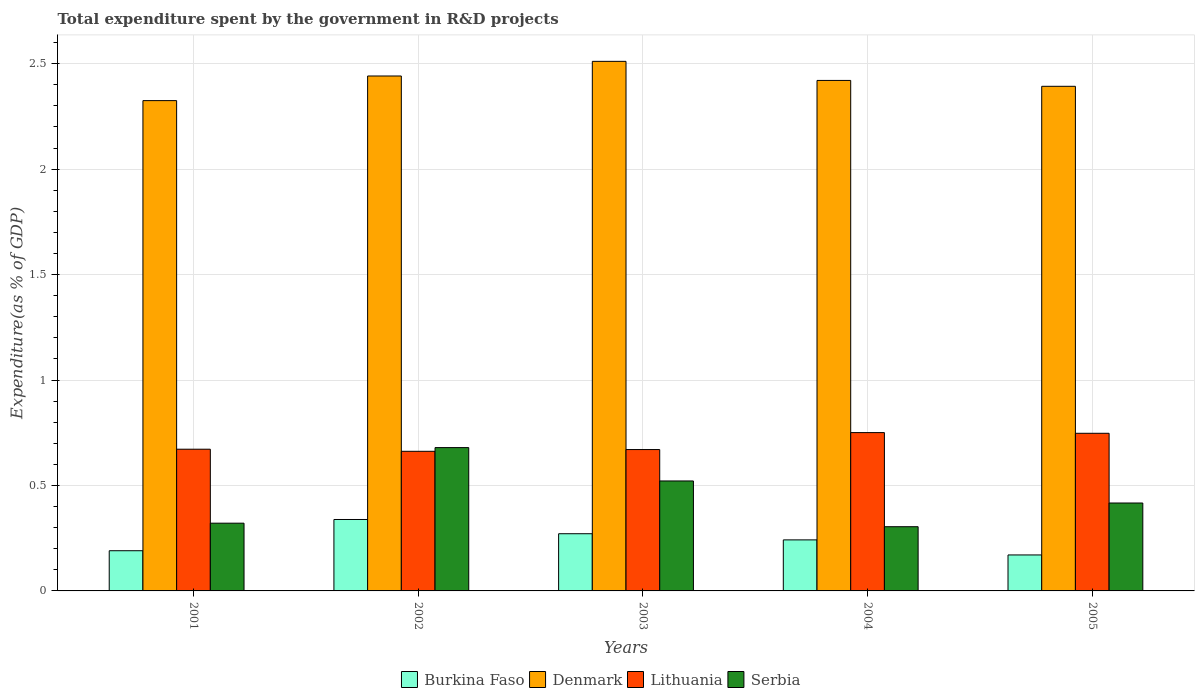How many different coloured bars are there?
Your answer should be very brief. 4. In how many cases, is the number of bars for a given year not equal to the number of legend labels?
Your answer should be compact. 0. What is the total expenditure spent by the government in R&D projects in Lithuania in 2001?
Offer a terse response. 0.67. Across all years, what is the maximum total expenditure spent by the government in R&D projects in Denmark?
Keep it short and to the point. 2.51. Across all years, what is the minimum total expenditure spent by the government in R&D projects in Denmark?
Give a very brief answer. 2.32. In which year was the total expenditure spent by the government in R&D projects in Burkina Faso minimum?
Provide a succinct answer. 2005. What is the total total expenditure spent by the government in R&D projects in Denmark in the graph?
Keep it short and to the point. 12.09. What is the difference between the total expenditure spent by the government in R&D projects in Serbia in 2002 and that in 2004?
Your answer should be very brief. 0.38. What is the difference between the total expenditure spent by the government in R&D projects in Burkina Faso in 2003 and the total expenditure spent by the government in R&D projects in Lithuania in 2004?
Make the answer very short. -0.48. What is the average total expenditure spent by the government in R&D projects in Burkina Faso per year?
Offer a terse response. 0.24. In the year 2004, what is the difference between the total expenditure spent by the government in R&D projects in Denmark and total expenditure spent by the government in R&D projects in Burkina Faso?
Offer a very short reply. 2.18. What is the ratio of the total expenditure spent by the government in R&D projects in Burkina Faso in 2002 to that in 2004?
Ensure brevity in your answer.  1.4. What is the difference between the highest and the second highest total expenditure spent by the government in R&D projects in Lithuania?
Offer a very short reply. 0. What is the difference between the highest and the lowest total expenditure spent by the government in R&D projects in Lithuania?
Offer a terse response. 0.09. Is the sum of the total expenditure spent by the government in R&D projects in Lithuania in 2003 and 2005 greater than the maximum total expenditure spent by the government in R&D projects in Denmark across all years?
Keep it short and to the point. No. Is it the case that in every year, the sum of the total expenditure spent by the government in R&D projects in Lithuania and total expenditure spent by the government in R&D projects in Burkina Faso is greater than the sum of total expenditure spent by the government in R&D projects in Serbia and total expenditure spent by the government in R&D projects in Denmark?
Your answer should be compact. Yes. What does the 1st bar from the left in 2004 represents?
Ensure brevity in your answer.  Burkina Faso. What does the 4th bar from the right in 2004 represents?
Keep it short and to the point. Burkina Faso. How many bars are there?
Keep it short and to the point. 20. Are all the bars in the graph horizontal?
Make the answer very short. No. Are the values on the major ticks of Y-axis written in scientific E-notation?
Ensure brevity in your answer.  No. How many legend labels are there?
Your answer should be very brief. 4. What is the title of the graph?
Give a very brief answer. Total expenditure spent by the government in R&D projects. Does "Latin America(developing only)" appear as one of the legend labels in the graph?
Offer a very short reply. No. What is the label or title of the X-axis?
Your answer should be compact. Years. What is the label or title of the Y-axis?
Give a very brief answer. Expenditure(as % of GDP). What is the Expenditure(as % of GDP) in Burkina Faso in 2001?
Your response must be concise. 0.19. What is the Expenditure(as % of GDP) in Denmark in 2001?
Offer a terse response. 2.32. What is the Expenditure(as % of GDP) of Lithuania in 2001?
Make the answer very short. 0.67. What is the Expenditure(as % of GDP) of Serbia in 2001?
Make the answer very short. 0.32. What is the Expenditure(as % of GDP) in Burkina Faso in 2002?
Keep it short and to the point. 0.34. What is the Expenditure(as % of GDP) in Denmark in 2002?
Your answer should be very brief. 2.44. What is the Expenditure(as % of GDP) in Lithuania in 2002?
Your answer should be compact. 0.66. What is the Expenditure(as % of GDP) of Serbia in 2002?
Your answer should be very brief. 0.68. What is the Expenditure(as % of GDP) of Burkina Faso in 2003?
Keep it short and to the point. 0.27. What is the Expenditure(as % of GDP) in Denmark in 2003?
Your answer should be very brief. 2.51. What is the Expenditure(as % of GDP) in Lithuania in 2003?
Ensure brevity in your answer.  0.67. What is the Expenditure(as % of GDP) in Serbia in 2003?
Keep it short and to the point. 0.52. What is the Expenditure(as % of GDP) of Burkina Faso in 2004?
Your answer should be very brief. 0.24. What is the Expenditure(as % of GDP) of Denmark in 2004?
Your answer should be very brief. 2.42. What is the Expenditure(as % of GDP) of Lithuania in 2004?
Your response must be concise. 0.75. What is the Expenditure(as % of GDP) of Serbia in 2004?
Your answer should be very brief. 0.3. What is the Expenditure(as % of GDP) in Burkina Faso in 2005?
Offer a terse response. 0.17. What is the Expenditure(as % of GDP) in Denmark in 2005?
Give a very brief answer. 2.39. What is the Expenditure(as % of GDP) of Lithuania in 2005?
Offer a terse response. 0.75. What is the Expenditure(as % of GDP) of Serbia in 2005?
Make the answer very short. 0.42. Across all years, what is the maximum Expenditure(as % of GDP) of Burkina Faso?
Provide a succinct answer. 0.34. Across all years, what is the maximum Expenditure(as % of GDP) in Denmark?
Your response must be concise. 2.51. Across all years, what is the maximum Expenditure(as % of GDP) of Lithuania?
Ensure brevity in your answer.  0.75. Across all years, what is the maximum Expenditure(as % of GDP) of Serbia?
Your answer should be very brief. 0.68. Across all years, what is the minimum Expenditure(as % of GDP) of Burkina Faso?
Your answer should be very brief. 0.17. Across all years, what is the minimum Expenditure(as % of GDP) in Denmark?
Ensure brevity in your answer.  2.32. Across all years, what is the minimum Expenditure(as % of GDP) of Lithuania?
Make the answer very short. 0.66. Across all years, what is the minimum Expenditure(as % of GDP) of Serbia?
Offer a very short reply. 0.3. What is the total Expenditure(as % of GDP) in Burkina Faso in the graph?
Provide a short and direct response. 1.21. What is the total Expenditure(as % of GDP) in Denmark in the graph?
Offer a terse response. 12.09. What is the total Expenditure(as % of GDP) of Lithuania in the graph?
Give a very brief answer. 3.5. What is the total Expenditure(as % of GDP) of Serbia in the graph?
Give a very brief answer. 2.24. What is the difference between the Expenditure(as % of GDP) of Burkina Faso in 2001 and that in 2002?
Provide a short and direct response. -0.15. What is the difference between the Expenditure(as % of GDP) in Denmark in 2001 and that in 2002?
Your answer should be compact. -0.12. What is the difference between the Expenditure(as % of GDP) in Lithuania in 2001 and that in 2002?
Provide a short and direct response. 0.01. What is the difference between the Expenditure(as % of GDP) of Serbia in 2001 and that in 2002?
Give a very brief answer. -0.36. What is the difference between the Expenditure(as % of GDP) of Burkina Faso in 2001 and that in 2003?
Keep it short and to the point. -0.08. What is the difference between the Expenditure(as % of GDP) of Denmark in 2001 and that in 2003?
Your answer should be compact. -0.19. What is the difference between the Expenditure(as % of GDP) in Lithuania in 2001 and that in 2003?
Make the answer very short. 0. What is the difference between the Expenditure(as % of GDP) in Serbia in 2001 and that in 2003?
Ensure brevity in your answer.  -0.2. What is the difference between the Expenditure(as % of GDP) of Burkina Faso in 2001 and that in 2004?
Provide a succinct answer. -0.05. What is the difference between the Expenditure(as % of GDP) in Denmark in 2001 and that in 2004?
Make the answer very short. -0.1. What is the difference between the Expenditure(as % of GDP) of Lithuania in 2001 and that in 2004?
Keep it short and to the point. -0.08. What is the difference between the Expenditure(as % of GDP) of Serbia in 2001 and that in 2004?
Make the answer very short. 0.02. What is the difference between the Expenditure(as % of GDP) in Denmark in 2001 and that in 2005?
Your response must be concise. -0.07. What is the difference between the Expenditure(as % of GDP) of Lithuania in 2001 and that in 2005?
Offer a terse response. -0.08. What is the difference between the Expenditure(as % of GDP) in Serbia in 2001 and that in 2005?
Give a very brief answer. -0.1. What is the difference between the Expenditure(as % of GDP) of Burkina Faso in 2002 and that in 2003?
Provide a succinct answer. 0.07. What is the difference between the Expenditure(as % of GDP) of Denmark in 2002 and that in 2003?
Your answer should be compact. -0.07. What is the difference between the Expenditure(as % of GDP) in Lithuania in 2002 and that in 2003?
Ensure brevity in your answer.  -0.01. What is the difference between the Expenditure(as % of GDP) of Serbia in 2002 and that in 2003?
Keep it short and to the point. 0.16. What is the difference between the Expenditure(as % of GDP) in Burkina Faso in 2002 and that in 2004?
Keep it short and to the point. 0.1. What is the difference between the Expenditure(as % of GDP) in Denmark in 2002 and that in 2004?
Keep it short and to the point. 0.02. What is the difference between the Expenditure(as % of GDP) in Lithuania in 2002 and that in 2004?
Provide a short and direct response. -0.09. What is the difference between the Expenditure(as % of GDP) in Serbia in 2002 and that in 2004?
Provide a short and direct response. 0.38. What is the difference between the Expenditure(as % of GDP) of Burkina Faso in 2002 and that in 2005?
Provide a succinct answer. 0.17. What is the difference between the Expenditure(as % of GDP) in Denmark in 2002 and that in 2005?
Keep it short and to the point. 0.05. What is the difference between the Expenditure(as % of GDP) in Lithuania in 2002 and that in 2005?
Provide a succinct answer. -0.09. What is the difference between the Expenditure(as % of GDP) in Serbia in 2002 and that in 2005?
Ensure brevity in your answer.  0.26. What is the difference between the Expenditure(as % of GDP) of Burkina Faso in 2003 and that in 2004?
Give a very brief answer. 0.03. What is the difference between the Expenditure(as % of GDP) in Denmark in 2003 and that in 2004?
Your answer should be compact. 0.09. What is the difference between the Expenditure(as % of GDP) in Lithuania in 2003 and that in 2004?
Make the answer very short. -0.08. What is the difference between the Expenditure(as % of GDP) in Serbia in 2003 and that in 2004?
Keep it short and to the point. 0.22. What is the difference between the Expenditure(as % of GDP) in Burkina Faso in 2003 and that in 2005?
Offer a terse response. 0.1. What is the difference between the Expenditure(as % of GDP) of Denmark in 2003 and that in 2005?
Offer a very short reply. 0.12. What is the difference between the Expenditure(as % of GDP) in Lithuania in 2003 and that in 2005?
Provide a succinct answer. -0.08. What is the difference between the Expenditure(as % of GDP) in Serbia in 2003 and that in 2005?
Your response must be concise. 0.1. What is the difference between the Expenditure(as % of GDP) in Burkina Faso in 2004 and that in 2005?
Your answer should be compact. 0.07. What is the difference between the Expenditure(as % of GDP) in Denmark in 2004 and that in 2005?
Your answer should be very brief. 0.03. What is the difference between the Expenditure(as % of GDP) in Lithuania in 2004 and that in 2005?
Offer a terse response. 0. What is the difference between the Expenditure(as % of GDP) in Serbia in 2004 and that in 2005?
Give a very brief answer. -0.11. What is the difference between the Expenditure(as % of GDP) in Burkina Faso in 2001 and the Expenditure(as % of GDP) in Denmark in 2002?
Ensure brevity in your answer.  -2.25. What is the difference between the Expenditure(as % of GDP) in Burkina Faso in 2001 and the Expenditure(as % of GDP) in Lithuania in 2002?
Your answer should be very brief. -0.47. What is the difference between the Expenditure(as % of GDP) of Burkina Faso in 2001 and the Expenditure(as % of GDP) of Serbia in 2002?
Offer a very short reply. -0.49. What is the difference between the Expenditure(as % of GDP) of Denmark in 2001 and the Expenditure(as % of GDP) of Lithuania in 2002?
Provide a succinct answer. 1.66. What is the difference between the Expenditure(as % of GDP) in Denmark in 2001 and the Expenditure(as % of GDP) in Serbia in 2002?
Keep it short and to the point. 1.65. What is the difference between the Expenditure(as % of GDP) in Lithuania in 2001 and the Expenditure(as % of GDP) in Serbia in 2002?
Provide a succinct answer. -0.01. What is the difference between the Expenditure(as % of GDP) in Burkina Faso in 2001 and the Expenditure(as % of GDP) in Denmark in 2003?
Keep it short and to the point. -2.32. What is the difference between the Expenditure(as % of GDP) in Burkina Faso in 2001 and the Expenditure(as % of GDP) in Lithuania in 2003?
Ensure brevity in your answer.  -0.48. What is the difference between the Expenditure(as % of GDP) in Burkina Faso in 2001 and the Expenditure(as % of GDP) in Serbia in 2003?
Give a very brief answer. -0.33. What is the difference between the Expenditure(as % of GDP) of Denmark in 2001 and the Expenditure(as % of GDP) of Lithuania in 2003?
Provide a succinct answer. 1.65. What is the difference between the Expenditure(as % of GDP) in Denmark in 2001 and the Expenditure(as % of GDP) in Serbia in 2003?
Offer a terse response. 1.8. What is the difference between the Expenditure(as % of GDP) of Lithuania in 2001 and the Expenditure(as % of GDP) of Serbia in 2003?
Your answer should be compact. 0.15. What is the difference between the Expenditure(as % of GDP) in Burkina Faso in 2001 and the Expenditure(as % of GDP) in Denmark in 2004?
Provide a succinct answer. -2.23. What is the difference between the Expenditure(as % of GDP) in Burkina Faso in 2001 and the Expenditure(as % of GDP) in Lithuania in 2004?
Your answer should be very brief. -0.56. What is the difference between the Expenditure(as % of GDP) in Burkina Faso in 2001 and the Expenditure(as % of GDP) in Serbia in 2004?
Your response must be concise. -0.11. What is the difference between the Expenditure(as % of GDP) in Denmark in 2001 and the Expenditure(as % of GDP) in Lithuania in 2004?
Make the answer very short. 1.57. What is the difference between the Expenditure(as % of GDP) of Denmark in 2001 and the Expenditure(as % of GDP) of Serbia in 2004?
Offer a terse response. 2.02. What is the difference between the Expenditure(as % of GDP) in Lithuania in 2001 and the Expenditure(as % of GDP) in Serbia in 2004?
Give a very brief answer. 0.37. What is the difference between the Expenditure(as % of GDP) in Burkina Faso in 2001 and the Expenditure(as % of GDP) in Denmark in 2005?
Make the answer very short. -2.2. What is the difference between the Expenditure(as % of GDP) of Burkina Faso in 2001 and the Expenditure(as % of GDP) of Lithuania in 2005?
Give a very brief answer. -0.56. What is the difference between the Expenditure(as % of GDP) in Burkina Faso in 2001 and the Expenditure(as % of GDP) in Serbia in 2005?
Offer a terse response. -0.23. What is the difference between the Expenditure(as % of GDP) of Denmark in 2001 and the Expenditure(as % of GDP) of Lithuania in 2005?
Provide a succinct answer. 1.58. What is the difference between the Expenditure(as % of GDP) in Denmark in 2001 and the Expenditure(as % of GDP) in Serbia in 2005?
Offer a terse response. 1.91. What is the difference between the Expenditure(as % of GDP) in Lithuania in 2001 and the Expenditure(as % of GDP) in Serbia in 2005?
Provide a succinct answer. 0.26. What is the difference between the Expenditure(as % of GDP) in Burkina Faso in 2002 and the Expenditure(as % of GDP) in Denmark in 2003?
Provide a succinct answer. -2.17. What is the difference between the Expenditure(as % of GDP) in Burkina Faso in 2002 and the Expenditure(as % of GDP) in Lithuania in 2003?
Provide a succinct answer. -0.33. What is the difference between the Expenditure(as % of GDP) in Burkina Faso in 2002 and the Expenditure(as % of GDP) in Serbia in 2003?
Provide a short and direct response. -0.18. What is the difference between the Expenditure(as % of GDP) of Denmark in 2002 and the Expenditure(as % of GDP) of Lithuania in 2003?
Provide a short and direct response. 1.77. What is the difference between the Expenditure(as % of GDP) of Denmark in 2002 and the Expenditure(as % of GDP) of Serbia in 2003?
Offer a terse response. 1.92. What is the difference between the Expenditure(as % of GDP) in Lithuania in 2002 and the Expenditure(as % of GDP) in Serbia in 2003?
Your answer should be compact. 0.14. What is the difference between the Expenditure(as % of GDP) in Burkina Faso in 2002 and the Expenditure(as % of GDP) in Denmark in 2004?
Your answer should be very brief. -2.08. What is the difference between the Expenditure(as % of GDP) of Burkina Faso in 2002 and the Expenditure(as % of GDP) of Lithuania in 2004?
Offer a very short reply. -0.41. What is the difference between the Expenditure(as % of GDP) in Burkina Faso in 2002 and the Expenditure(as % of GDP) in Serbia in 2004?
Keep it short and to the point. 0.03. What is the difference between the Expenditure(as % of GDP) in Denmark in 2002 and the Expenditure(as % of GDP) in Lithuania in 2004?
Ensure brevity in your answer.  1.69. What is the difference between the Expenditure(as % of GDP) of Denmark in 2002 and the Expenditure(as % of GDP) of Serbia in 2004?
Your answer should be very brief. 2.14. What is the difference between the Expenditure(as % of GDP) of Lithuania in 2002 and the Expenditure(as % of GDP) of Serbia in 2004?
Make the answer very short. 0.36. What is the difference between the Expenditure(as % of GDP) in Burkina Faso in 2002 and the Expenditure(as % of GDP) in Denmark in 2005?
Offer a terse response. -2.05. What is the difference between the Expenditure(as % of GDP) in Burkina Faso in 2002 and the Expenditure(as % of GDP) in Lithuania in 2005?
Your answer should be compact. -0.41. What is the difference between the Expenditure(as % of GDP) in Burkina Faso in 2002 and the Expenditure(as % of GDP) in Serbia in 2005?
Your response must be concise. -0.08. What is the difference between the Expenditure(as % of GDP) of Denmark in 2002 and the Expenditure(as % of GDP) of Lithuania in 2005?
Provide a succinct answer. 1.69. What is the difference between the Expenditure(as % of GDP) of Denmark in 2002 and the Expenditure(as % of GDP) of Serbia in 2005?
Offer a terse response. 2.02. What is the difference between the Expenditure(as % of GDP) in Lithuania in 2002 and the Expenditure(as % of GDP) in Serbia in 2005?
Provide a short and direct response. 0.25. What is the difference between the Expenditure(as % of GDP) in Burkina Faso in 2003 and the Expenditure(as % of GDP) in Denmark in 2004?
Provide a succinct answer. -2.15. What is the difference between the Expenditure(as % of GDP) in Burkina Faso in 2003 and the Expenditure(as % of GDP) in Lithuania in 2004?
Provide a short and direct response. -0.48. What is the difference between the Expenditure(as % of GDP) of Burkina Faso in 2003 and the Expenditure(as % of GDP) of Serbia in 2004?
Keep it short and to the point. -0.03. What is the difference between the Expenditure(as % of GDP) of Denmark in 2003 and the Expenditure(as % of GDP) of Lithuania in 2004?
Your response must be concise. 1.76. What is the difference between the Expenditure(as % of GDP) of Denmark in 2003 and the Expenditure(as % of GDP) of Serbia in 2004?
Keep it short and to the point. 2.21. What is the difference between the Expenditure(as % of GDP) in Lithuania in 2003 and the Expenditure(as % of GDP) in Serbia in 2004?
Offer a terse response. 0.37. What is the difference between the Expenditure(as % of GDP) of Burkina Faso in 2003 and the Expenditure(as % of GDP) of Denmark in 2005?
Offer a terse response. -2.12. What is the difference between the Expenditure(as % of GDP) of Burkina Faso in 2003 and the Expenditure(as % of GDP) of Lithuania in 2005?
Offer a terse response. -0.48. What is the difference between the Expenditure(as % of GDP) of Burkina Faso in 2003 and the Expenditure(as % of GDP) of Serbia in 2005?
Give a very brief answer. -0.15. What is the difference between the Expenditure(as % of GDP) of Denmark in 2003 and the Expenditure(as % of GDP) of Lithuania in 2005?
Keep it short and to the point. 1.76. What is the difference between the Expenditure(as % of GDP) of Denmark in 2003 and the Expenditure(as % of GDP) of Serbia in 2005?
Provide a short and direct response. 2.09. What is the difference between the Expenditure(as % of GDP) of Lithuania in 2003 and the Expenditure(as % of GDP) of Serbia in 2005?
Your response must be concise. 0.25. What is the difference between the Expenditure(as % of GDP) of Burkina Faso in 2004 and the Expenditure(as % of GDP) of Denmark in 2005?
Provide a succinct answer. -2.15. What is the difference between the Expenditure(as % of GDP) in Burkina Faso in 2004 and the Expenditure(as % of GDP) in Lithuania in 2005?
Your answer should be compact. -0.51. What is the difference between the Expenditure(as % of GDP) in Burkina Faso in 2004 and the Expenditure(as % of GDP) in Serbia in 2005?
Your answer should be very brief. -0.17. What is the difference between the Expenditure(as % of GDP) of Denmark in 2004 and the Expenditure(as % of GDP) of Lithuania in 2005?
Your answer should be very brief. 1.67. What is the difference between the Expenditure(as % of GDP) of Denmark in 2004 and the Expenditure(as % of GDP) of Serbia in 2005?
Your response must be concise. 2. What is the difference between the Expenditure(as % of GDP) in Lithuania in 2004 and the Expenditure(as % of GDP) in Serbia in 2005?
Offer a terse response. 0.33. What is the average Expenditure(as % of GDP) in Burkina Faso per year?
Give a very brief answer. 0.24. What is the average Expenditure(as % of GDP) in Denmark per year?
Provide a succinct answer. 2.42. What is the average Expenditure(as % of GDP) in Lithuania per year?
Keep it short and to the point. 0.7. What is the average Expenditure(as % of GDP) of Serbia per year?
Offer a terse response. 0.45. In the year 2001, what is the difference between the Expenditure(as % of GDP) in Burkina Faso and Expenditure(as % of GDP) in Denmark?
Provide a succinct answer. -2.13. In the year 2001, what is the difference between the Expenditure(as % of GDP) of Burkina Faso and Expenditure(as % of GDP) of Lithuania?
Provide a short and direct response. -0.48. In the year 2001, what is the difference between the Expenditure(as % of GDP) of Burkina Faso and Expenditure(as % of GDP) of Serbia?
Your response must be concise. -0.13. In the year 2001, what is the difference between the Expenditure(as % of GDP) in Denmark and Expenditure(as % of GDP) in Lithuania?
Your response must be concise. 1.65. In the year 2001, what is the difference between the Expenditure(as % of GDP) of Denmark and Expenditure(as % of GDP) of Serbia?
Your answer should be compact. 2. In the year 2001, what is the difference between the Expenditure(as % of GDP) in Lithuania and Expenditure(as % of GDP) in Serbia?
Provide a succinct answer. 0.35. In the year 2002, what is the difference between the Expenditure(as % of GDP) of Burkina Faso and Expenditure(as % of GDP) of Denmark?
Offer a terse response. -2.1. In the year 2002, what is the difference between the Expenditure(as % of GDP) of Burkina Faso and Expenditure(as % of GDP) of Lithuania?
Your answer should be compact. -0.32. In the year 2002, what is the difference between the Expenditure(as % of GDP) of Burkina Faso and Expenditure(as % of GDP) of Serbia?
Provide a succinct answer. -0.34. In the year 2002, what is the difference between the Expenditure(as % of GDP) in Denmark and Expenditure(as % of GDP) in Lithuania?
Provide a short and direct response. 1.78. In the year 2002, what is the difference between the Expenditure(as % of GDP) in Denmark and Expenditure(as % of GDP) in Serbia?
Your answer should be compact. 1.76. In the year 2002, what is the difference between the Expenditure(as % of GDP) of Lithuania and Expenditure(as % of GDP) of Serbia?
Your answer should be very brief. -0.02. In the year 2003, what is the difference between the Expenditure(as % of GDP) of Burkina Faso and Expenditure(as % of GDP) of Denmark?
Offer a terse response. -2.24. In the year 2003, what is the difference between the Expenditure(as % of GDP) of Burkina Faso and Expenditure(as % of GDP) of Lithuania?
Provide a succinct answer. -0.4. In the year 2003, what is the difference between the Expenditure(as % of GDP) of Burkina Faso and Expenditure(as % of GDP) of Serbia?
Your answer should be compact. -0.25. In the year 2003, what is the difference between the Expenditure(as % of GDP) in Denmark and Expenditure(as % of GDP) in Lithuania?
Offer a very short reply. 1.84. In the year 2003, what is the difference between the Expenditure(as % of GDP) in Denmark and Expenditure(as % of GDP) in Serbia?
Provide a short and direct response. 1.99. In the year 2003, what is the difference between the Expenditure(as % of GDP) in Lithuania and Expenditure(as % of GDP) in Serbia?
Your answer should be very brief. 0.15. In the year 2004, what is the difference between the Expenditure(as % of GDP) of Burkina Faso and Expenditure(as % of GDP) of Denmark?
Your answer should be very brief. -2.18. In the year 2004, what is the difference between the Expenditure(as % of GDP) of Burkina Faso and Expenditure(as % of GDP) of Lithuania?
Provide a succinct answer. -0.51. In the year 2004, what is the difference between the Expenditure(as % of GDP) in Burkina Faso and Expenditure(as % of GDP) in Serbia?
Provide a succinct answer. -0.06. In the year 2004, what is the difference between the Expenditure(as % of GDP) in Denmark and Expenditure(as % of GDP) in Lithuania?
Your answer should be compact. 1.67. In the year 2004, what is the difference between the Expenditure(as % of GDP) in Denmark and Expenditure(as % of GDP) in Serbia?
Offer a terse response. 2.12. In the year 2004, what is the difference between the Expenditure(as % of GDP) of Lithuania and Expenditure(as % of GDP) of Serbia?
Keep it short and to the point. 0.45. In the year 2005, what is the difference between the Expenditure(as % of GDP) of Burkina Faso and Expenditure(as % of GDP) of Denmark?
Keep it short and to the point. -2.22. In the year 2005, what is the difference between the Expenditure(as % of GDP) of Burkina Faso and Expenditure(as % of GDP) of Lithuania?
Offer a very short reply. -0.58. In the year 2005, what is the difference between the Expenditure(as % of GDP) of Burkina Faso and Expenditure(as % of GDP) of Serbia?
Keep it short and to the point. -0.25. In the year 2005, what is the difference between the Expenditure(as % of GDP) of Denmark and Expenditure(as % of GDP) of Lithuania?
Ensure brevity in your answer.  1.65. In the year 2005, what is the difference between the Expenditure(as % of GDP) in Denmark and Expenditure(as % of GDP) in Serbia?
Provide a succinct answer. 1.98. In the year 2005, what is the difference between the Expenditure(as % of GDP) in Lithuania and Expenditure(as % of GDP) in Serbia?
Your answer should be very brief. 0.33. What is the ratio of the Expenditure(as % of GDP) of Burkina Faso in 2001 to that in 2002?
Offer a terse response. 0.56. What is the ratio of the Expenditure(as % of GDP) of Denmark in 2001 to that in 2002?
Offer a very short reply. 0.95. What is the ratio of the Expenditure(as % of GDP) of Lithuania in 2001 to that in 2002?
Give a very brief answer. 1.01. What is the ratio of the Expenditure(as % of GDP) in Serbia in 2001 to that in 2002?
Ensure brevity in your answer.  0.47. What is the ratio of the Expenditure(as % of GDP) of Burkina Faso in 2001 to that in 2003?
Ensure brevity in your answer.  0.7. What is the ratio of the Expenditure(as % of GDP) in Denmark in 2001 to that in 2003?
Make the answer very short. 0.93. What is the ratio of the Expenditure(as % of GDP) of Lithuania in 2001 to that in 2003?
Make the answer very short. 1. What is the ratio of the Expenditure(as % of GDP) of Serbia in 2001 to that in 2003?
Offer a very short reply. 0.62. What is the ratio of the Expenditure(as % of GDP) of Burkina Faso in 2001 to that in 2004?
Ensure brevity in your answer.  0.79. What is the ratio of the Expenditure(as % of GDP) in Denmark in 2001 to that in 2004?
Keep it short and to the point. 0.96. What is the ratio of the Expenditure(as % of GDP) in Lithuania in 2001 to that in 2004?
Your answer should be compact. 0.9. What is the ratio of the Expenditure(as % of GDP) in Serbia in 2001 to that in 2004?
Your answer should be compact. 1.05. What is the ratio of the Expenditure(as % of GDP) in Burkina Faso in 2001 to that in 2005?
Give a very brief answer. 1.12. What is the ratio of the Expenditure(as % of GDP) in Denmark in 2001 to that in 2005?
Your answer should be compact. 0.97. What is the ratio of the Expenditure(as % of GDP) in Lithuania in 2001 to that in 2005?
Provide a succinct answer. 0.9. What is the ratio of the Expenditure(as % of GDP) in Serbia in 2001 to that in 2005?
Provide a succinct answer. 0.77. What is the ratio of the Expenditure(as % of GDP) of Burkina Faso in 2002 to that in 2003?
Your answer should be very brief. 1.25. What is the ratio of the Expenditure(as % of GDP) in Denmark in 2002 to that in 2003?
Provide a succinct answer. 0.97. What is the ratio of the Expenditure(as % of GDP) in Lithuania in 2002 to that in 2003?
Offer a very short reply. 0.99. What is the ratio of the Expenditure(as % of GDP) of Serbia in 2002 to that in 2003?
Your response must be concise. 1.3. What is the ratio of the Expenditure(as % of GDP) in Burkina Faso in 2002 to that in 2004?
Your answer should be very brief. 1.4. What is the ratio of the Expenditure(as % of GDP) in Denmark in 2002 to that in 2004?
Your response must be concise. 1.01. What is the ratio of the Expenditure(as % of GDP) of Lithuania in 2002 to that in 2004?
Give a very brief answer. 0.88. What is the ratio of the Expenditure(as % of GDP) of Serbia in 2002 to that in 2004?
Your answer should be compact. 2.23. What is the ratio of the Expenditure(as % of GDP) of Burkina Faso in 2002 to that in 2005?
Make the answer very short. 1.99. What is the ratio of the Expenditure(as % of GDP) of Denmark in 2002 to that in 2005?
Offer a very short reply. 1.02. What is the ratio of the Expenditure(as % of GDP) in Lithuania in 2002 to that in 2005?
Offer a very short reply. 0.89. What is the ratio of the Expenditure(as % of GDP) of Serbia in 2002 to that in 2005?
Your answer should be compact. 1.63. What is the ratio of the Expenditure(as % of GDP) in Burkina Faso in 2003 to that in 2004?
Your answer should be compact. 1.12. What is the ratio of the Expenditure(as % of GDP) of Denmark in 2003 to that in 2004?
Your response must be concise. 1.04. What is the ratio of the Expenditure(as % of GDP) in Lithuania in 2003 to that in 2004?
Your response must be concise. 0.89. What is the ratio of the Expenditure(as % of GDP) in Serbia in 2003 to that in 2004?
Provide a short and direct response. 1.71. What is the ratio of the Expenditure(as % of GDP) in Burkina Faso in 2003 to that in 2005?
Your response must be concise. 1.59. What is the ratio of the Expenditure(as % of GDP) of Denmark in 2003 to that in 2005?
Offer a terse response. 1.05. What is the ratio of the Expenditure(as % of GDP) in Lithuania in 2003 to that in 2005?
Ensure brevity in your answer.  0.9. What is the ratio of the Expenditure(as % of GDP) of Serbia in 2003 to that in 2005?
Provide a short and direct response. 1.25. What is the ratio of the Expenditure(as % of GDP) of Burkina Faso in 2004 to that in 2005?
Give a very brief answer. 1.42. What is the ratio of the Expenditure(as % of GDP) of Denmark in 2004 to that in 2005?
Your answer should be very brief. 1.01. What is the ratio of the Expenditure(as % of GDP) in Lithuania in 2004 to that in 2005?
Provide a short and direct response. 1. What is the ratio of the Expenditure(as % of GDP) in Serbia in 2004 to that in 2005?
Give a very brief answer. 0.73. What is the difference between the highest and the second highest Expenditure(as % of GDP) in Burkina Faso?
Offer a very short reply. 0.07. What is the difference between the highest and the second highest Expenditure(as % of GDP) of Denmark?
Offer a terse response. 0.07. What is the difference between the highest and the second highest Expenditure(as % of GDP) of Lithuania?
Provide a short and direct response. 0. What is the difference between the highest and the second highest Expenditure(as % of GDP) in Serbia?
Your answer should be compact. 0.16. What is the difference between the highest and the lowest Expenditure(as % of GDP) of Burkina Faso?
Provide a short and direct response. 0.17. What is the difference between the highest and the lowest Expenditure(as % of GDP) in Denmark?
Make the answer very short. 0.19. What is the difference between the highest and the lowest Expenditure(as % of GDP) of Lithuania?
Provide a short and direct response. 0.09. What is the difference between the highest and the lowest Expenditure(as % of GDP) in Serbia?
Your answer should be compact. 0.38. 